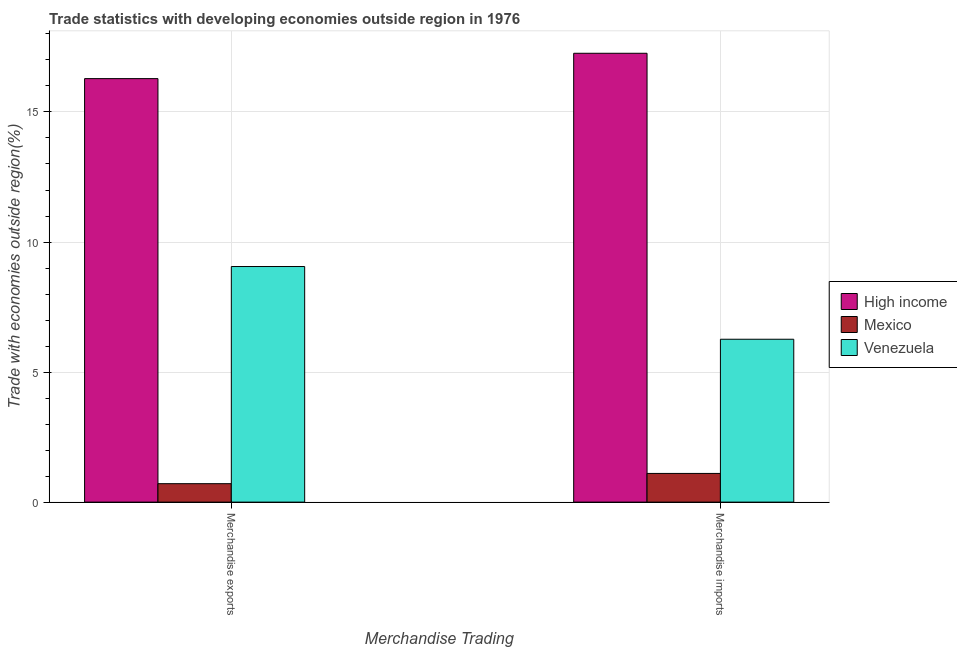Are the number of bars per tick equal to the number of legend labels?
Your answer should be very brief. Yes. How many bars are there on the 1st tick from the left?
Give a very brief answer. 3. How many bars are there on the 1st tick from the right?
Your answer should be compact. 3. What is the merchandise exports in High income?
Your answer should be very brief. 16.28. Across all countries, what is the maximum merchandise imports?
Provide a short and direct response. 17.26. Across all countries, what is the minimum merchandise imports?
Give a very brief answer. 1.1. In which country was the merchandise imports maximum?
Keep it short and to the point. High income. In which country was the merchandise exports minimum?
Keep it short and to the point. Mexico. What is the total merchandise exports in the graph?
Your answer should be compact. 26.05. What is the difference between the merchandise imports in High income and that in Venezuela?
Give a very brief answer. 10.99. What is the difference between the merchandise imports in Venezuela and the merchandise exports in High income?
Your response must be concise. -10.02. What is the average merchandise exports per country?
Your answer should be very brief. 8.68. What is the difference between the merchandise imports and merchandise exports in High income?
Make the answer very short. 0.97. In how many countries, is the merchandise imports greater than 2 %?
Give a very brief answer. 2. What is the ratio of the merchandise exports in Venezuela to that in High income?
Your answer should be very brief. 0.56. Is the merchandise exports in Venezuela less than that in High income?
Your answer should be very brief. Yes. In how many countries, is the merchandise imports greater than the average merchandise imports taken over all countries?
Provide a succinct answer. 1. What does the 3rd bar from the right in Merchandise exports represents?
Your response must be concise. High income. How many countries are there in the graph?
Keep it short and to the point. 3. Are the values on the major ticks of Y-axis written in scientific E-notation?
Offer a terse response. No. Where does the legend appear in the graph?
Your response must be concise. Center right. How are the legend labels stacked?
Make the answer very short. Vertical. What is the title of the graph?
Offer a terse response. Trade statistics with developing economies outside region in 1976. What is the label or title of the X-axis?
Your answer should be very brief. Merchandise Trading. What is the label or title of the Y-axis?
Keep it short and to the point. Trade with economies outside region(%). What is the Trade with economies outside region(%) of High income in Merchandise exports?
Your response must be concise. 16.28. What is the Trade with economies outside region(%) in Mexico in Merchandise exports?
Provide a short and direct response. 0.71. What is the Trade with economies outside region(%) of Venezuela in Merchandise exports?
Make the answer very short. 9.06. What is the Trade with economies outside region(%) of High income in Merchandise imports?
Offer a very short reply. 17.26. What is the Trade with economies outside region(%) of Mexico in Merchandise imports?
Your answer should be compact. 1.1. What is the Trade with economies outside region(%) in Venezuela in Merchandise imports?
Keep it short and to the point. 6.26. Across all Merchandise Trading, what is the maximum Trade with economies outside region(%) in High income?
Offer a very short reply. 17.26. Across all Merchandise Trading, what is the maximum Trade with economies outside region(%) of Mexico?
Provide a short and direct response. 1.1. Across all Merchandise Trading, what is the maximum Trade with economies outside region(%) of Venezuela?
Offer a very short reply. 9.06. Across all Merchandise Trading, what is the minimum Trade with economies outside region(%) of High income?
Provide a succinct answer. 16.28. Across all Merchandise Trading, what is the minimum Trade with economies outside region(%) of Mexico?
Your response must be concise. 0.71. Across all Merchandise Trading, what is the minimum Trade with economies outside region(%) in Venezuela?
Provide a succinct answer. 6.26. What is the total Trade with economies outside region(%) in High income in the graph?
Keep it short and to the point. 33.54. What is the total Trade with economies outside region(%) of Mexico in the graph?
Keep it short and to the point. 1.81. What is the total Trade with economies outside region(%) of Venezuela in the graph?
Offer a very short reply. 15.32. What is the difference between the Trade with economies outside region(%) of High income in Merchandise exports and that in Merchandise imports?
Your answer should be compact. -0.97. What is the difference between the Trade with economies outside region(%) of Mexico in Merchandise exports and that in Merchandise imports?
Your answer should be compact. -0.39. What is the difference between the Trade with economies outside region(%) in Venezuela in Merchandise exports and that in Merchandise imports?
Your answer should be compact. 2.8. What is the difference between the Trade with economies outside region(%) in High income in Merchandise exports and the Trade with economies outside region(%) in Mexico in Merchandise imports?
Provide a short and direct response. 15.18. What is the difference between the Trade with economies outside region(%) in High income in Merchandise exports and the Trade with economies outside region(%) in Venezuela in Merchandise imports?
Provide a succinct answer. 10.02. What is the difference between the Trade with economies outside region(%) of Mexico in Merchandise exports and the Trade with economies outside region(%) of Venezuela in Merchandise imports?
Keep it short and to the point. -5.55. What is the average Trade with economies outside region(%) of High income per Merchandise Trading?
Keep it short and to the point. 16.77. What is the average Trade with economies outside region(%) in Mexico per Merchandise Trading?
Give a very brief answer. 0.91. What is the average Trade with economies outside region(%) of Venezuela per Merchandise Trading?
Your response must be concise. 7.66. What is the difference between the Trade with economies outside region(%) of High income and Trade with economies outside region(%) of Mexico in Merchandise exports?
Ensure brevity in your answer.  15.57. What is the difference between the Trade with economies outside region(%) of High income and Trade with economies outside region(%) of Venezuela in Merchandise exports?
Ensure brevity in your answer.  7.22. What is the difference between the Trade with economies outside region(%) of Mexico and Trade with economies outside region(%) of Venezuela in Merchandise exports?
Offer a terse response. -8.35. What is the difference between the Trade with economies outside region(%) in High income and Trade with economies outside region(%) in Mexico in Merchandise imports?
Give a very brief answer. 16.15. What is the difference between the Trade with economies outside region(%) of High income and Trade with economies outside region(%) of Venezuela in Merchandise imports?
Make the answer very short. 10.99. What is the difference between the Trade with economies outside region(%) in Mexico and Trade with economies outside region(%) in Venezuela in Merchandise imports?
Keep it short and to the point. -5.16. What is the ratio of the Trade with economies outside region(%) in High income in Merchandise exports to that in Merchandise imports?
Provide a succinct answer. 0.94. What is the ratio of the Trade with economies outside region(%) in Mexico in Merchandise exports to that in Merchandise imports?
Your answer should be compact. 0.64. What is the ratio of the Trade with economies outside region(%) in Venezuela in Merchandise exports to that in Merchandise imports?
Give a very brief answer. 1.45. What is the difference between the highest and the second highest Trade with economies outside region(%) of High income?
Keep it short and to the point. 0.97. What is the difference between the highest and the second highest Trade with economies outside region(%) in Mexico?
Provide a short and direct response. 0.39. What is the difference between the highest and the second highest Trade with economies outside region(%) of Venezuela?
Keep it short and to the point. 2.8. What is the difference between the highest and the lowest Trade with economies outside region(%) in High income?
Provide a short and direct response. 0.97. What is the difference between the highest and the lowest Trade with economies outside region(%) of Mexico?
Your response must be concise. 0.39. What is the difference between the highest and the lowest Trade with economies outside region(%) in Venezuela?
Make the answer very short. 2.8. 